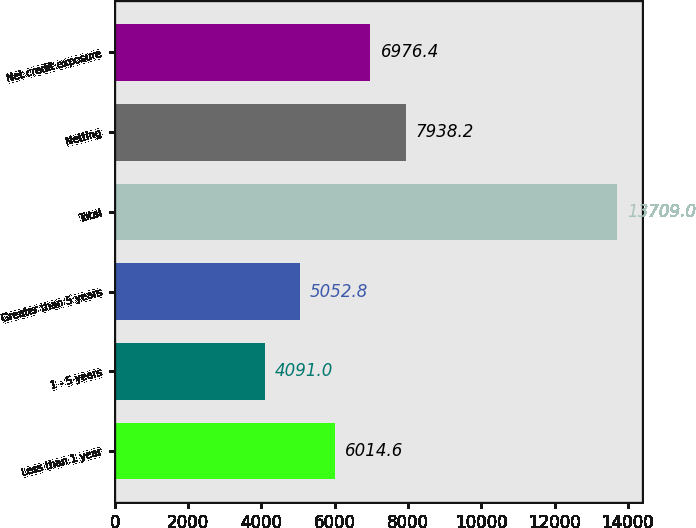<chart> <loc_0><loc_0><loc_500><loc_500><bar_chart><fcel>Less than 1 year<fcel>1 - 5 years<fcel>Greater than 5 years<fcel>Total<fcel>Netting<fcel>Net credit exposure<nl><fcel>6014.6<fcel>4091<fcel>5052.8<fcel>13709<fcel>7938.2<fcel>6976.4<nl></chart> 